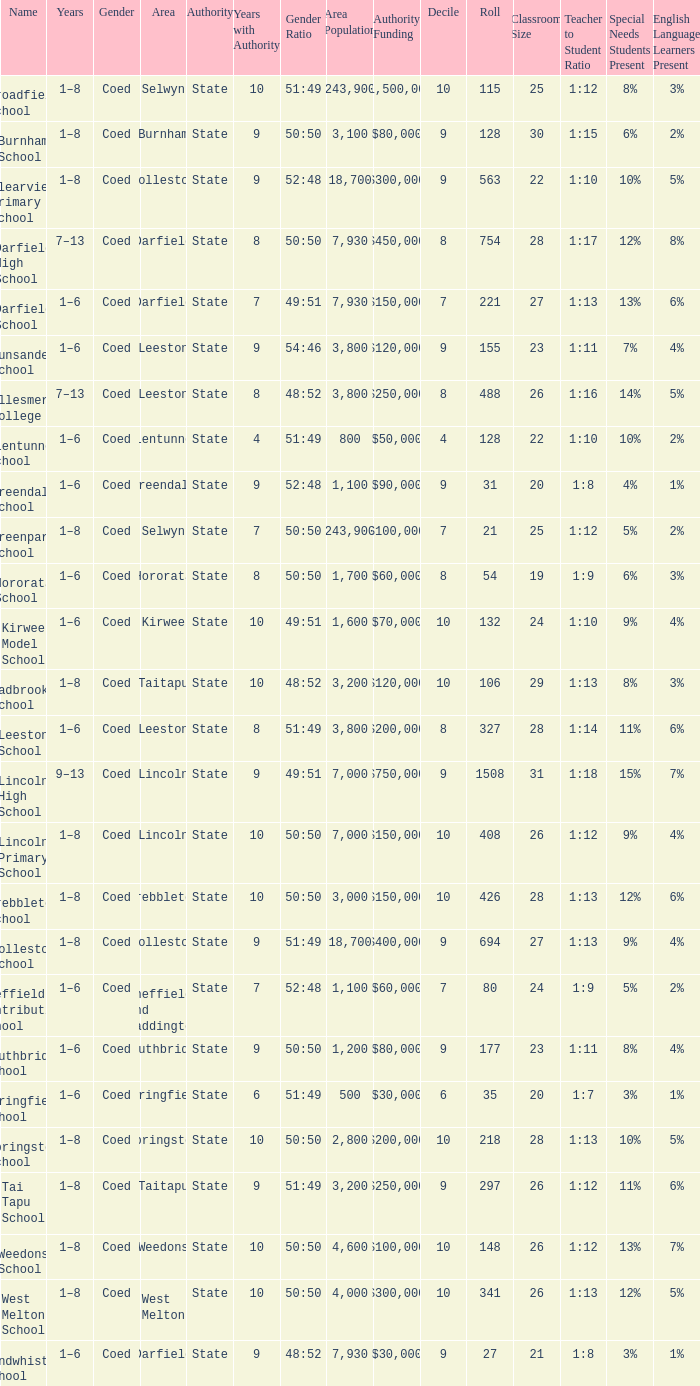Would you mind parsing the complete table? {'header': ['Name', 'Years', 'Gender', 'Area', 'Authority', 'Years with Authority', 'Gender Ratio', 'Area Population', 'Authority Funding', 'Decile', 'Roll', 'Classroom Size', 'Teacher to Student Ratio', 'Special Needs Students Present', 'English Language Learners Present '], 'rows': [['Broadfield School', '1–8', 'Coed', 'Selwyn', 'State', '10', '51:49', '243,900', '$1,500,000', '10', '115', '25', '1:12', '8%', '3%'], ['Burnham School', '1–8', 'Coed', 'Burnham', 'State', '9', '50:50', '3,100', '$80,000', '9', '128', '30', '1:15', '6%', '2%'], ['Clearview Primary School', '1–8', 'Coed', 'Rolleston', 'State', '9', '52:48', '18,700', '$300,000', '9', '563', '22', '1:10', '10%', '5%'], ['Darfield High School', '7–13', 'Coed', 'Darfield', 'State', '8', '50:50', '7,930', '$450,000', '8', '754', '28', '1:17', '12%', '8%'], ['Darfield School', '1–6', 'Coed', 'Darfield', 'State', '7', '49:51', '7,930', '$150,000', '7', '221', '27', '1:13', '13%', '6%'], ['Dunsandel School', '1–6', 'Coed', 'Leeston', 'State', '9', '54:46', '3,800', '$120,000', '9', '155', '23', '1:11', '7%', '4%'], ['Ellesmere College', '7–13', 'Coed', 'Leeston', 'State', '8', '48:52', '3,800', '$250,000', '8', '488', '26', '1:16', '14%', '5%'], ['Glentunnel School', '1–6', 'Coed', 'Glentunnel', 'State', '4', '51:49', '800', '$50,000', '4', '128', '22', '1:10', '10%', '2%'], ['Greendale School', '1–6', 'Coed', 'Greendale', 'State', '9', '52:48', '1,100', '$90,000', '9', '31', '20', '1:8', '4%', '1%'], ['Greenpark School', '1–8', 'Coed', 'Selwyn', 'State', '7', '50:50', '243,900', '$100,000', '7', '21', '25', '1:12', '5%', '2%'], ['Hororata School', '1–6', 'Coed', 'Hororata', 'State', '8', '50:50', '1,700', '$60,000', '8', '54', '19', '1:9', '6%', '3%'], ['Kirwee Model School', '1–6', 'Coed', 'Kirwee', 'State', '10', '49:51', '1,600', '$70,000', '10', '132', '24', '1:10', '9%', '4%'], ['Ladbrooks School', '1–8', 'Coed', 'Taitapu', 'State', '10', '48:52', '3,200', '$120,000', '10', '106', '29', '1:13', '8%', '3%'], ['Leeston School', '1–6', 'Coed', 'Leeston', 'State', '8', '51:49', '3,800', '$200,000', '8', '327', '28', '1:14', '11%', '6%'], ['Lincoln High School', '9–13', 'Coed', 'Lincoln', 'State', '9', '49:51', '7,000', '$750,000', '9', '1508', '31', '1:18', '15%', '7%'], ['Lincoln Primary School', '1–8', 'Coed', 'Lincoln', 'State', '10', '50:50', '7,000', '$150,000', '10', '408', '26', '1:12', '9%', '4%'], ['Prebbleton School', '1–8', 'Coed', 'Prebbleton', 'State', '10', '50:50', '3,000', '$150,000', '10', '426', '28', '1:13', '12%', '6%'], ['Rolleston School', '1–8', 'Coed', 'Rolleston', 'State', '9', '51:49', '18,700', '$400,000', '9', '694', '27', '1:13', '9%', '4%'], ['Sheffield Contributing School', '1–6', 'Coed', 'Sheffield and Waddington', 'State', '7', '52:48', '1,100', '$60,000', '7', '80', '24', '1:9', '5%', '2%'], ['Southbridge School', '1–6', 'Coed', 'Southbridge', 'State', '9', '50:50', '1,200', '$80,000', '9', '177', '23', '1:11', '8%', '4%'], ['Springfield School', '1–6', 'Coed', 'Springfield', 'State', '6', '51:49', '500', '$30,000', '6', '35', '20', '1:7', '3%', '1%'], ['Springston School', '1–8', 'Coed', 'Springston', 'State', '10', '50:50', '2,800', '$200,000', '10', '218', '28', '1:13', '10%', '5%'], ['Tai Tapu School', '1–8', 'Coed', 'Taitapu', 'State', '9', '51:49', '3,200', '$250,000', '9', '297', '26', '1:12', '11%', '6%'], ['Weedons School', '1–8', 'Coed', 'Weedons', 'State', '10', '50:50', '4,600', '$100,000', '10', '148', '26', '1:12', '13%', '7%'], ['West Melton School', '1–8', 'Coed', 'West Melton', 'State', '10', '50:50', '4,000', '$300,000', '10', '341', '26', '1:13', '12%', '5%'], ['Windwhistle School', '1–6', 'Coed', 'Darfield', 'State', '9', '48:52', '7,930', '$30,000', '9', '27', '21', '1:8', '3%', '1%']]} Which years have a Name of ladbrooks school? 1–8. 